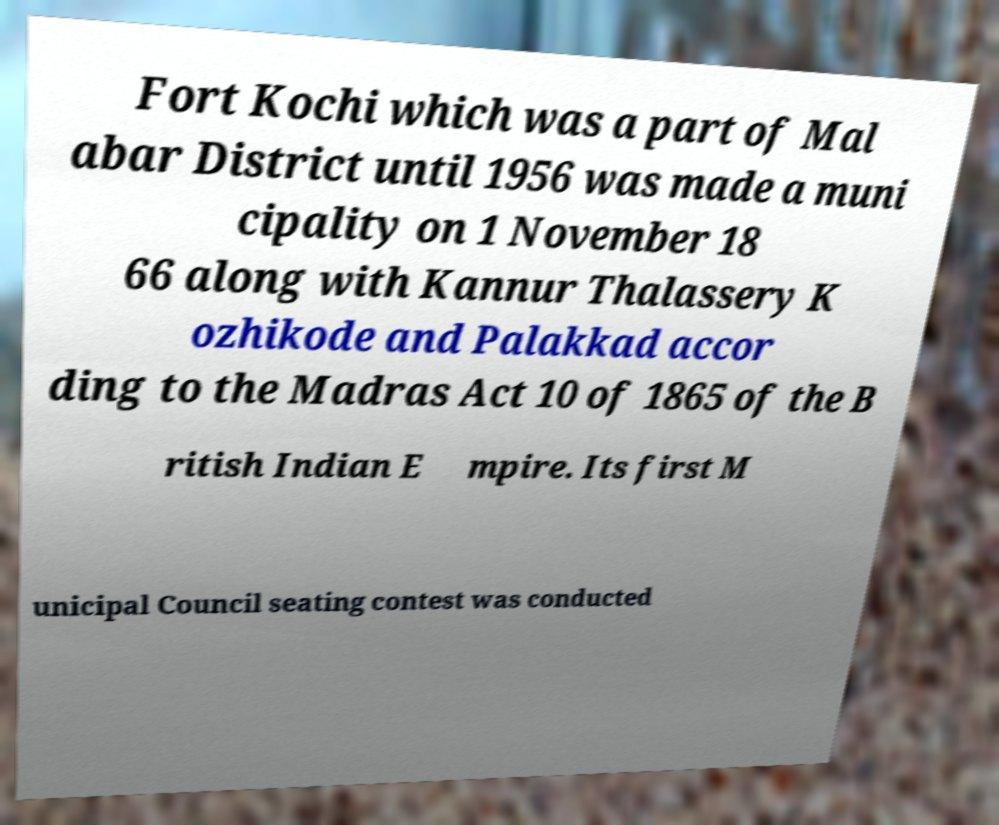For documentation purposes, I need the text within this image transcribed. Could you provide that? Fort Kochi which was a part of Mal abar District until 1956 was made a muni cipality on 1 November 18 66 along with Kannur Thalassery K ozhikode and Palakkad accor ding to the Madras Act 10 of 1865 of the B ritish Indian E mpire. Its first M unicipal Council seating contest was conducted 